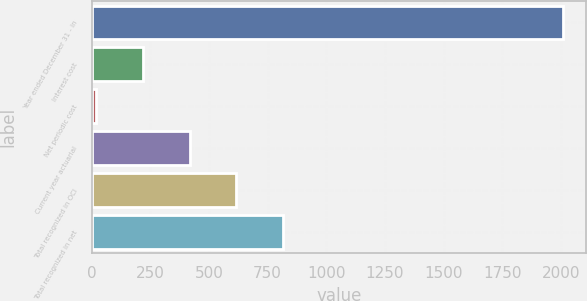Convert chart to OTSL. <chart><loc_0><loc_0><loc_500><loc_500><bar_chart><fcel>Year ended December 31 - in<fcel>Interest cost<fcel>Net periodic cost<fcel>Current year actuarial<fcel>Total recognized in OCI<fcel>Total recognized in net<nl><fcel>2009<fcel>218.9<fcel>20<fcel>417.8<fcel>616.7<fcel>815.6<nl></chart> 